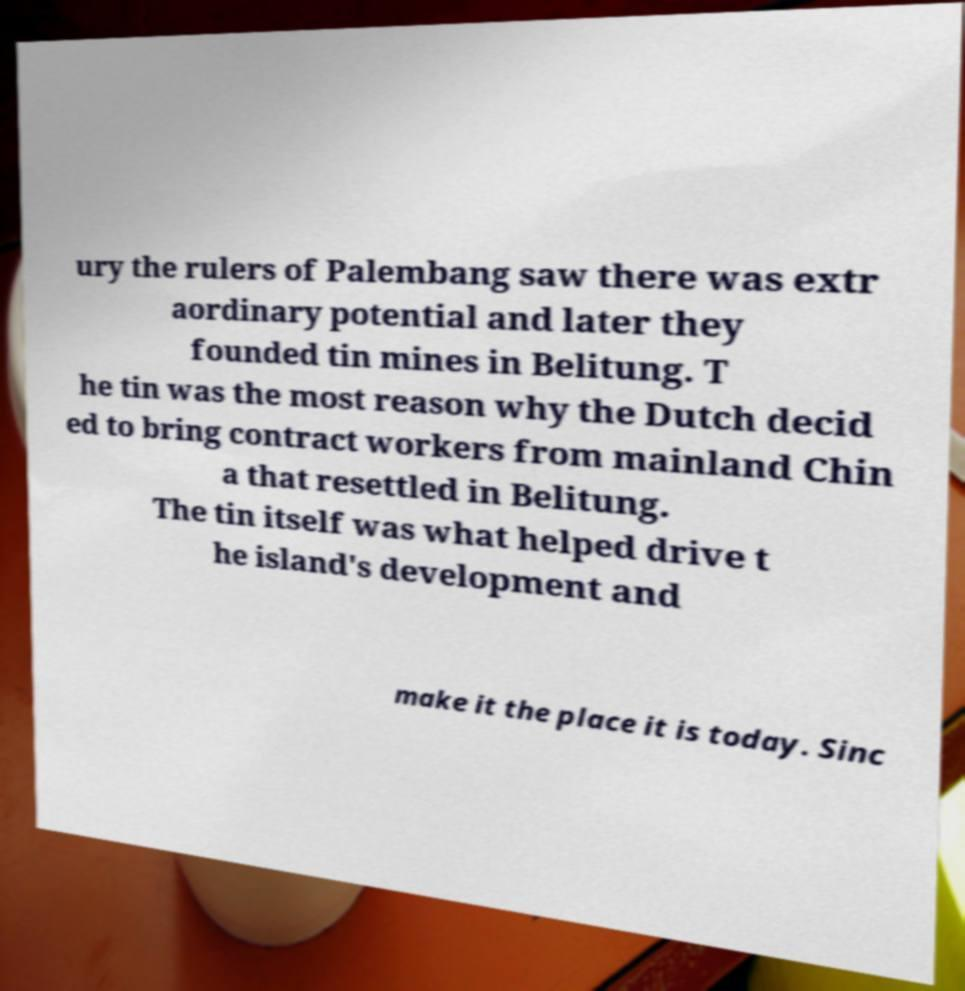Can you accurately transcribe the text from the provided image for me? ury the rulers of Palembang saw there was extr aordinary potential and later they founded tin mines in Belitung. T he tin was the most reason why the Dutch decid ed to bring contract workers from mainland Chin a that resettled in Belitung. The tin itself was what helped drive t he island's development and make it the place it is today. Sinc 